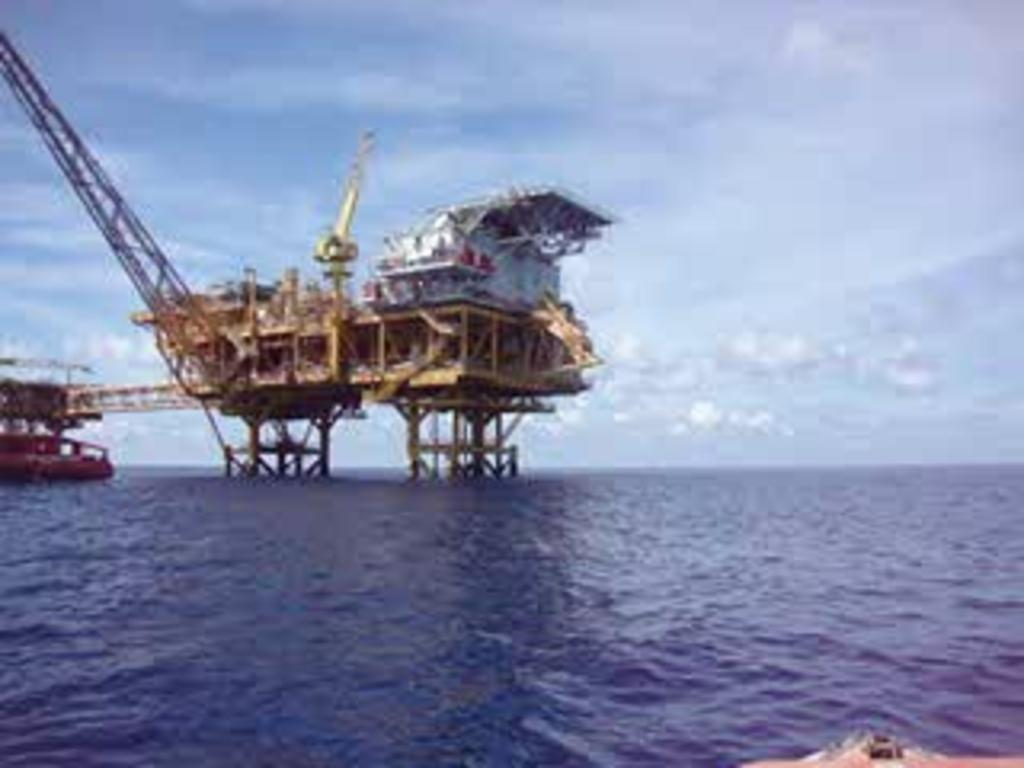What type of structure can be seen in the image? There is a bridge in the image. What other objects or vehicles are present in the image? There is a crane and boats on the water in the image. What can be seen in the background of the image? The sky is visible in the background of the image. What is the condition of the sky in the image? There are clouds in the sky in the image. What type of sound can be heard coming from the maid in the image? There is no maid present in the image, so it is not possible to determine what sound might be heard. 